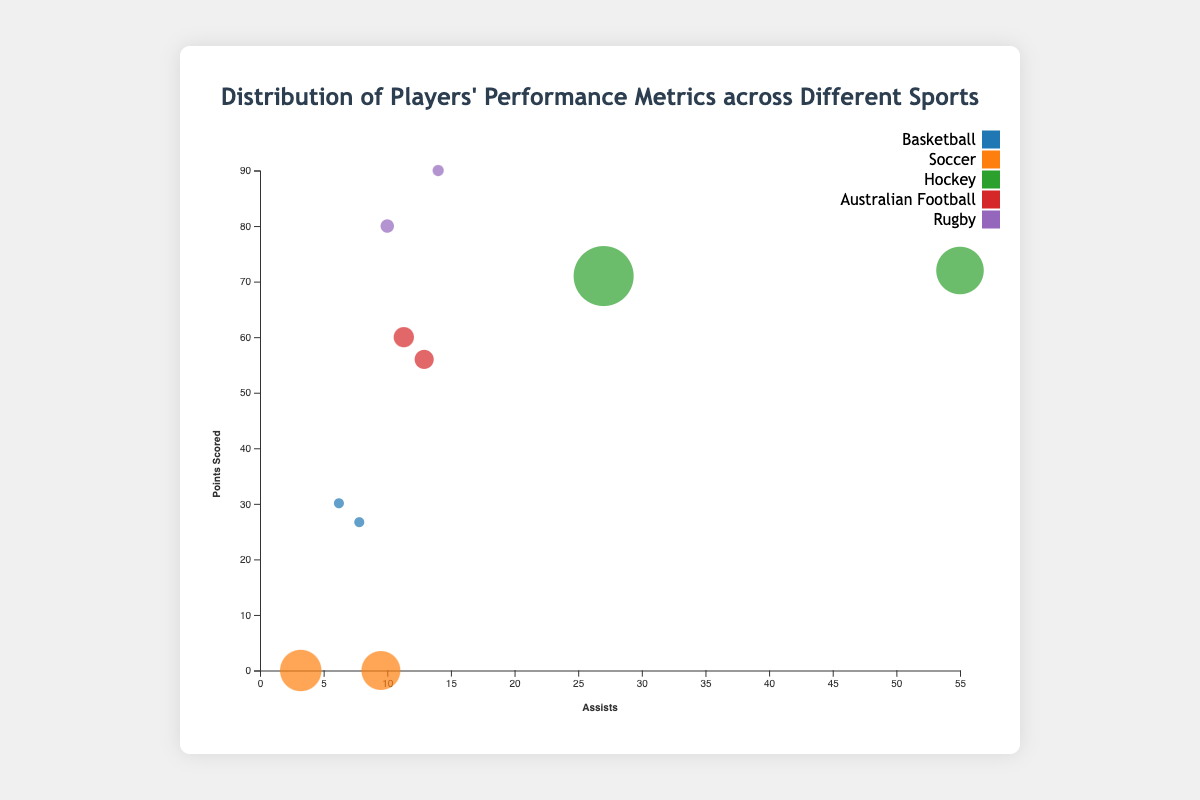How many sports are represented in the bubble chart? The chart uses different colors for each sport. Counting the unique colors or reading the legend will give the number of sports.
Answer: 5 Which player has the highest points scored in Rugby? Look for the largest y-axis value among the bubbles assigned to Rugby players.
Answer: Beauden Barrett What is the average number of assists for Basketball players? Find the assists values for LeBron James and Stephen Curry, sum them up, and divide by the number of players (i.e., (7.8 + 6.2) / 2).
Answer: 7 How do the goals scored by Cristiano Ronaldo and Lionel Messi compare? Find the bubble sizes for Cristiano Ronaldo and Lionel Messi in Soccer, and compare the two values.
Answer: Cristiano Ronaldo has more goals than Lionel Messi Which sport has the player with the highest number of assists? Identify the bubble with the highest x-axis value across the chart and note the sport in the tooltip.
Answer: Hockey What is the total points scored by players in Australian Football? Add the points scored by Dustin Martin and Nat Fyfe (i.e., 56 + 60).
Answer: 116 How does the points scored by Owen Farrell compare to Beauden Barrett? Compare the y-axis values for the bubbles representing Owen Farrell and Beauden Barrett in Rugby.
Answer: Owen Farrell has fewer points than Beauden Barrett Which player in Soccer has the higher number of assists? Compare the x-axis value for Lionel Messi and Cristiano Ronaldo within the Soccer category.
Answer: Lionel Messi What is the color representing Hockey in the chart? Identify the color used for Hockey in the legend.
Answer: (depends on the color scheme used, for example, blue) Are there any players who have zero goals scored? Look for bubbles with a size of zero and check the respective players.
Answer: LeBron James and Stephen Curry 